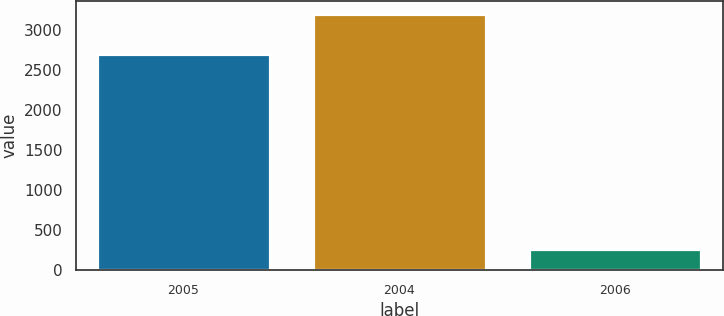<chart> <loc_0><loc_0><loc_500><loc_500><bar_chart><fcel>2005<fcel>2004<fcel>2006<nl><fcel>2701<fcel>3208<fcel>270<nl></chart> 